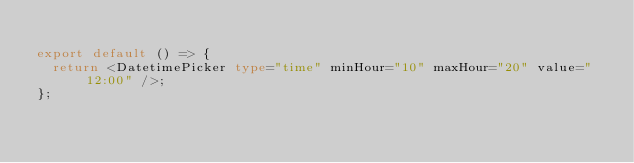Convert code to text. <code><loc_0><loc_0><loc_500><loc_500><_TypeScript_>
export default () => {
  return <DatetimePicker type="time" minHour="10" maxHour="20" value="12:00" />;
};
</code> 